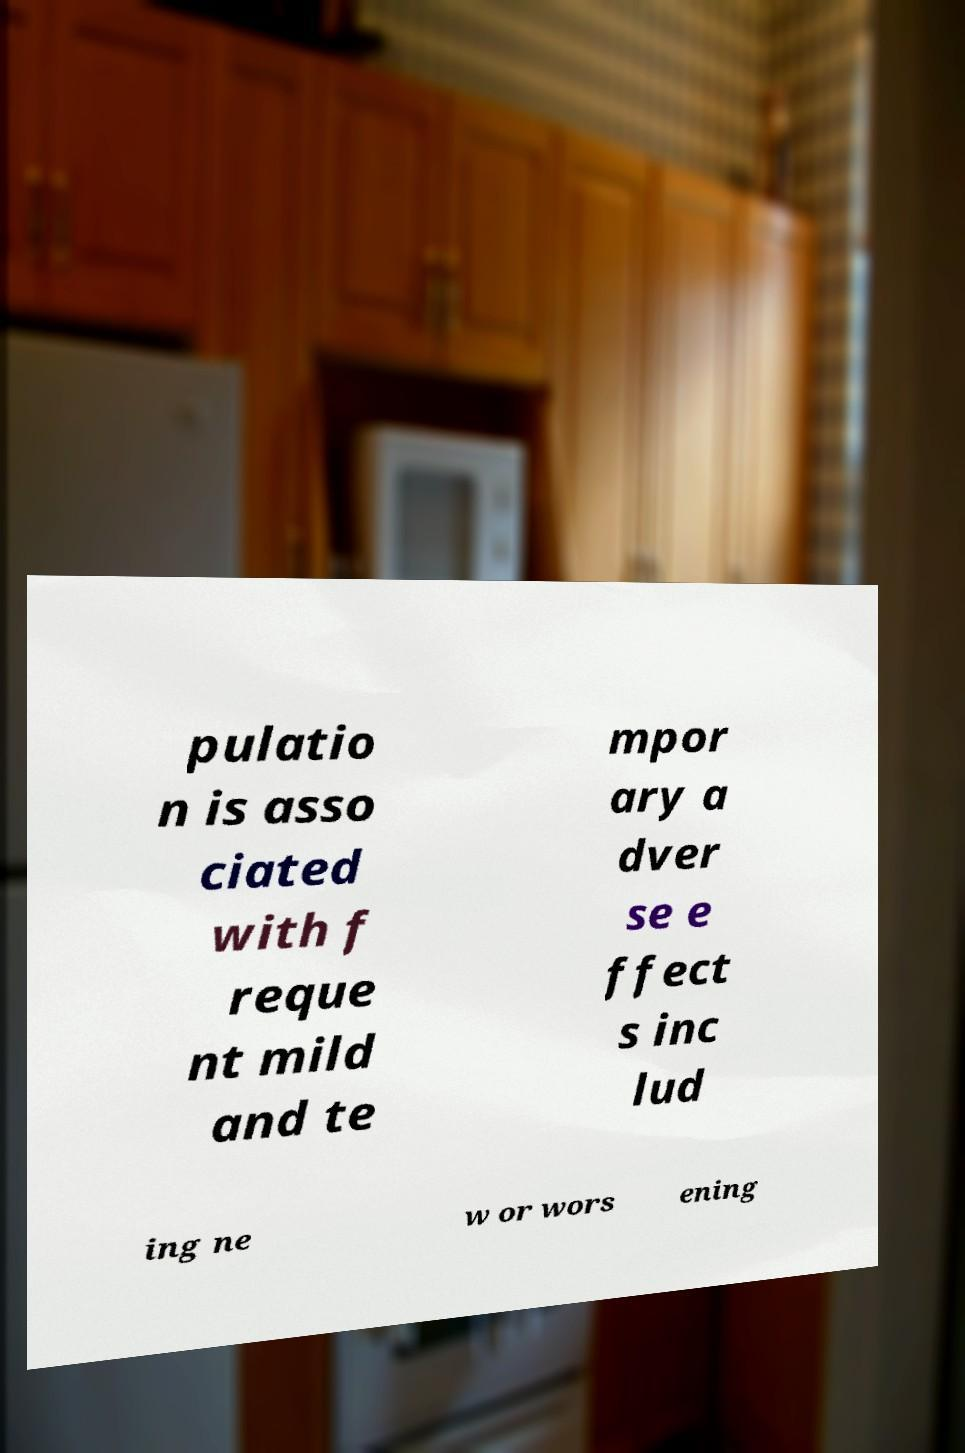Can you read and provide the text displayed in the image?This photo seems to have some interesting text. Can you extract and type it out for me? pulatio n is asso ciated with f reque nt mild and te mpor ary a dver se e ffect s inc lud ing ne w or wors ening 